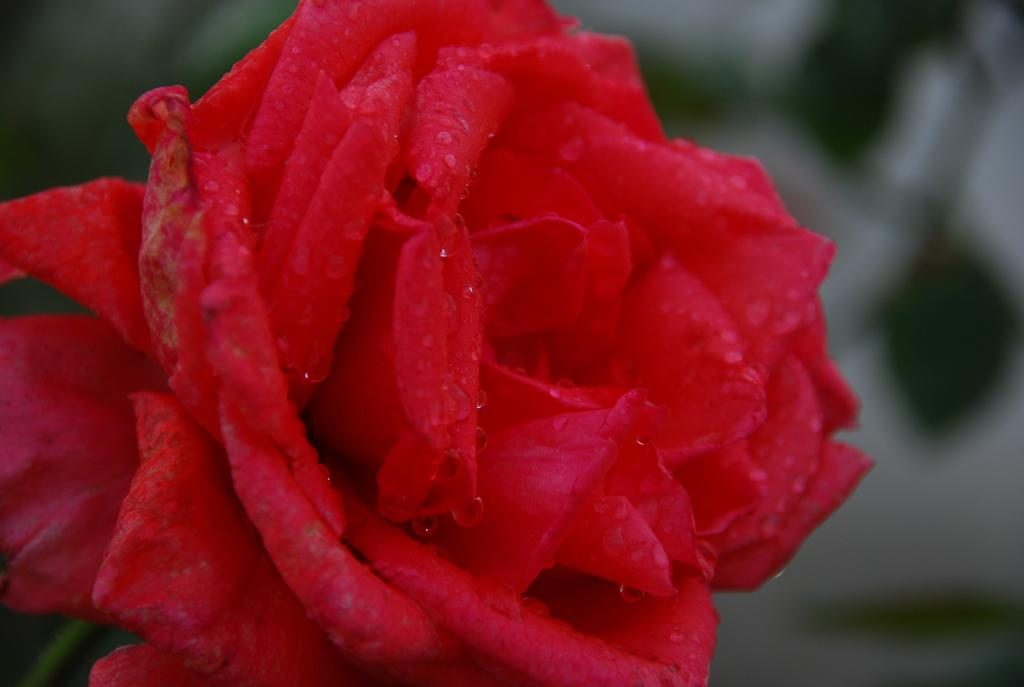What type of flower is present in the image? There is a red rose in the image. What discovery was made by the rat in the image? There is no rat present in the image, and therefore no discovery can be observed. 